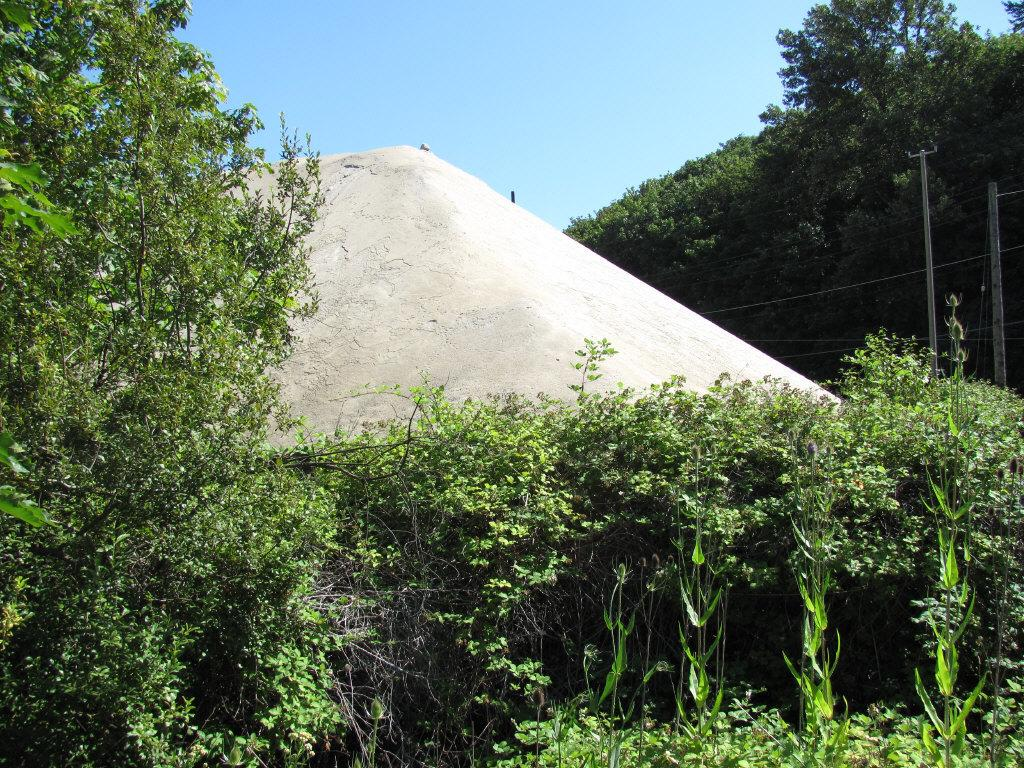What type of vegetation is visible in the image? There are trees and plants visible in the image. What is the color of the sky in the image? The sky is blue in the image. What type of structure can be seen in the image? There is a current pole in the image. What type of trousers can be seen hanging on the current pole in the image? There are no trousers present on the current pole or in the image. What type of farming equipment can be seen in the image? There is no farming equipment, such as a plough, present in the image. 